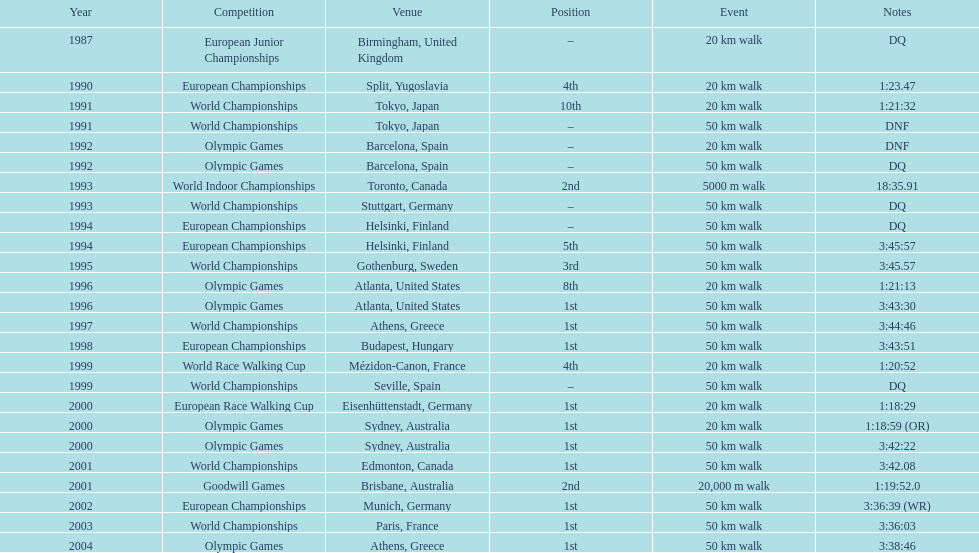In what year was korzeniowski's last tournament? 2004. 